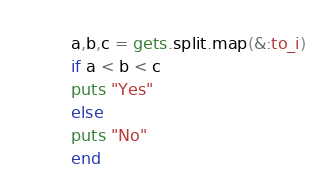Convert code to text. <code><loc_0><loc_0><loc_500><loc_500><_Ruby_>a,b,c = gets.split.map(&:to_i)
if a < b < c 
puts "Yes"
else 
puts "No"
end</code> 